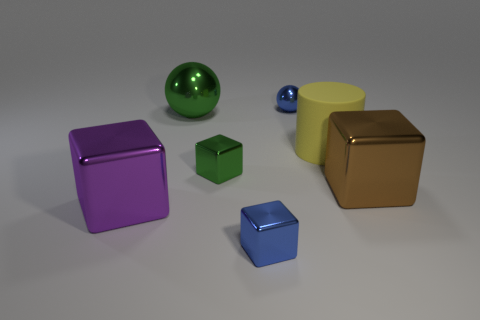The big thing that is both left of the rubber cylinder and in front of the small green cube is what color?
Your answer should be very brief. Purple. How many other things are there of the same color as the large metallic ball?
Your answer should be compact. 1. There is a big cube that is in front of the large metal thing that is to the right of the green ball that is on the right side of the big purple cube; what is its material?
Keep it short and to the point. Metal. How many cubes are big shiny things or purple things?
Your answer should be compact. 2. Is there any other thing that has the same size as the blue shiny cube?
Keep it short and to the point. Yes. There is a tiny metal block that is behind the big cube that is left of the yellow object; what number of large metal blocks are right of it?
Your response must be concise. 1. Do the large purple thing and the small green object have the same shape?
Keep it short and to the point. Yes. Is the material of the big cube that is on the right side of the yellow cylinder the same as the sphere that is in front of the small blue sphere?
Your answer should be very brief. Yes. How many things are either green objects that are to the left of the green cube or cubes that are on the right side of the tiny green metal object?
Offer a very short reply. 3. Is there anything else that is the same shape as the big purple object?
Give a very brief answer. Yes. 